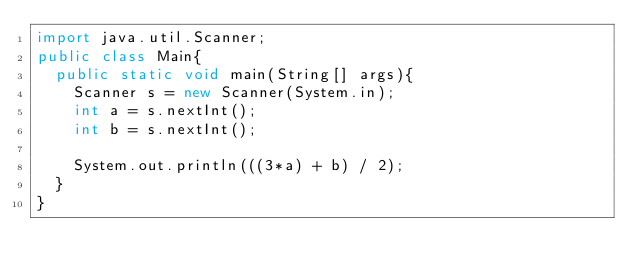<code> <loc_0><loc_0><loc_500><loc_500><_Java_>import java.util.Scanner;
public class Main{
  public static void main(String[] args){
    Scanner s = new Scanner(System.in);
    int a = s.nextInt();
    int b = s.nextInt();

    System.out.println(((3*a) + b) / 2);
  }
}
</code> 